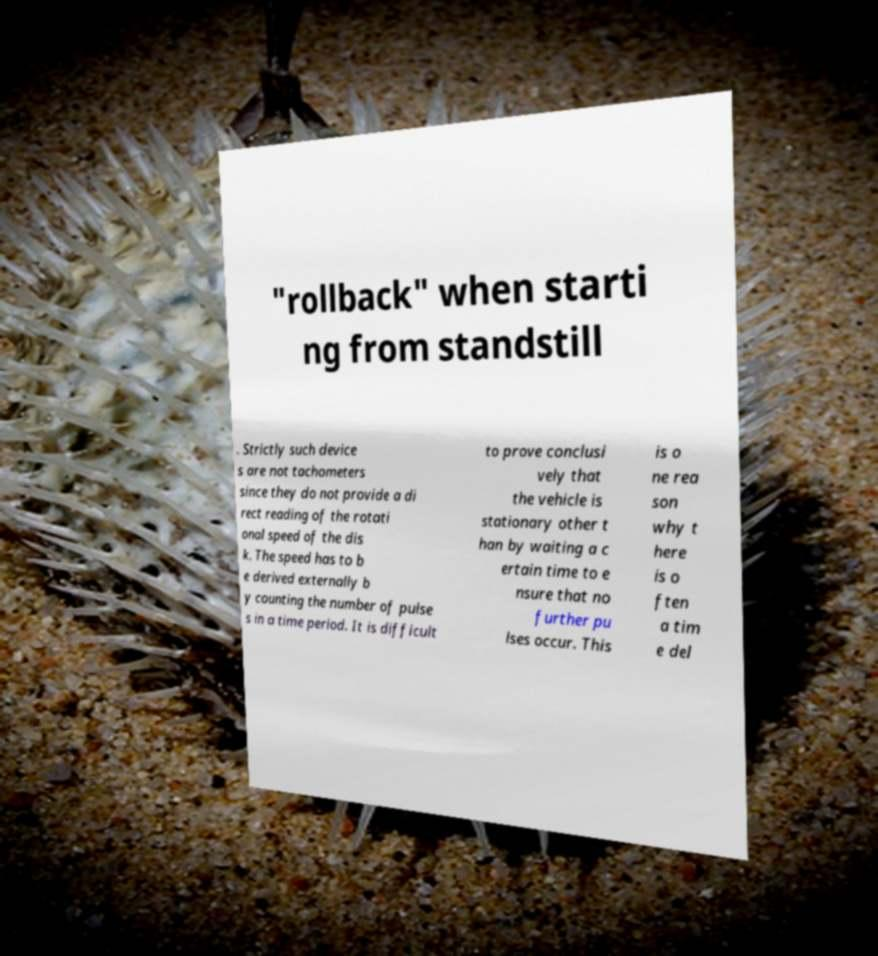For documentation purposes, I need the text within this image transcribed. Could you provide that? "rollback" when starti ng from standstill . Strictly such device s are not tachometers since they do not provide a di rect reading of the rotati onal speed of the dis k. The speed has to b e derived externally b y counting the number of pulse s in a time period. It is difficult to prove conclusi vely that the vehicle is stationary other t han by waiting a c ertain time to e nsure that no further pu lses occur. This is o ne rea son why t here is o ften a tim e del 